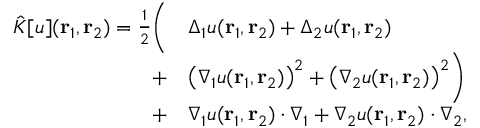<formula> <loc_0><loc_0><loc_500><loc_500>\begin{array} { r l } { \hat { K } [ u ] ( { r _ { 1 } } , { r _ { 2 } } ) = \frac { 1 } { 2 } \left ( } & { \Delta _ { 1 } u ( { r _ { 1 } } , { r _ { 2 } } ) + \Delta _ { 2 } u ( { r _ { 1 } } , { r _ { 2 } } ) } \\ { + } & { \left ( \nabla _ { 1 } u ( { r _ { 1 } } , { r _ { 2 } } ) \right ) ^ { 2 } + \left ( \nabla _ { 2 } u ( { r _ { 1 } } , { r _ { 2 } } ) \right ) ^ { 2 } \right ) } \\ { + } & { \nabla _ { 1 } u ( { r _ { 1 } } , { r _ { 2 } } ) \cdot \nabla _ { 1 } + \nabla _ { 2 } u ( { r _ { 1 } } , { r _ { 2 } } ) \cdot \nabla _ { 2 } , } \end{array}</formula> 